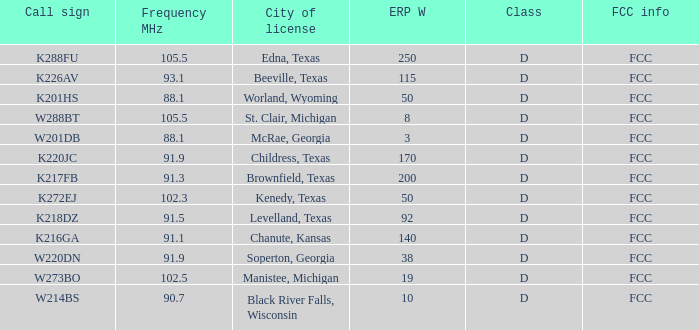What is Call Sign, when ERP W is greater than 50? K216GA, K226AV, K217FB, K220JC, K288FU, K218DZ. 